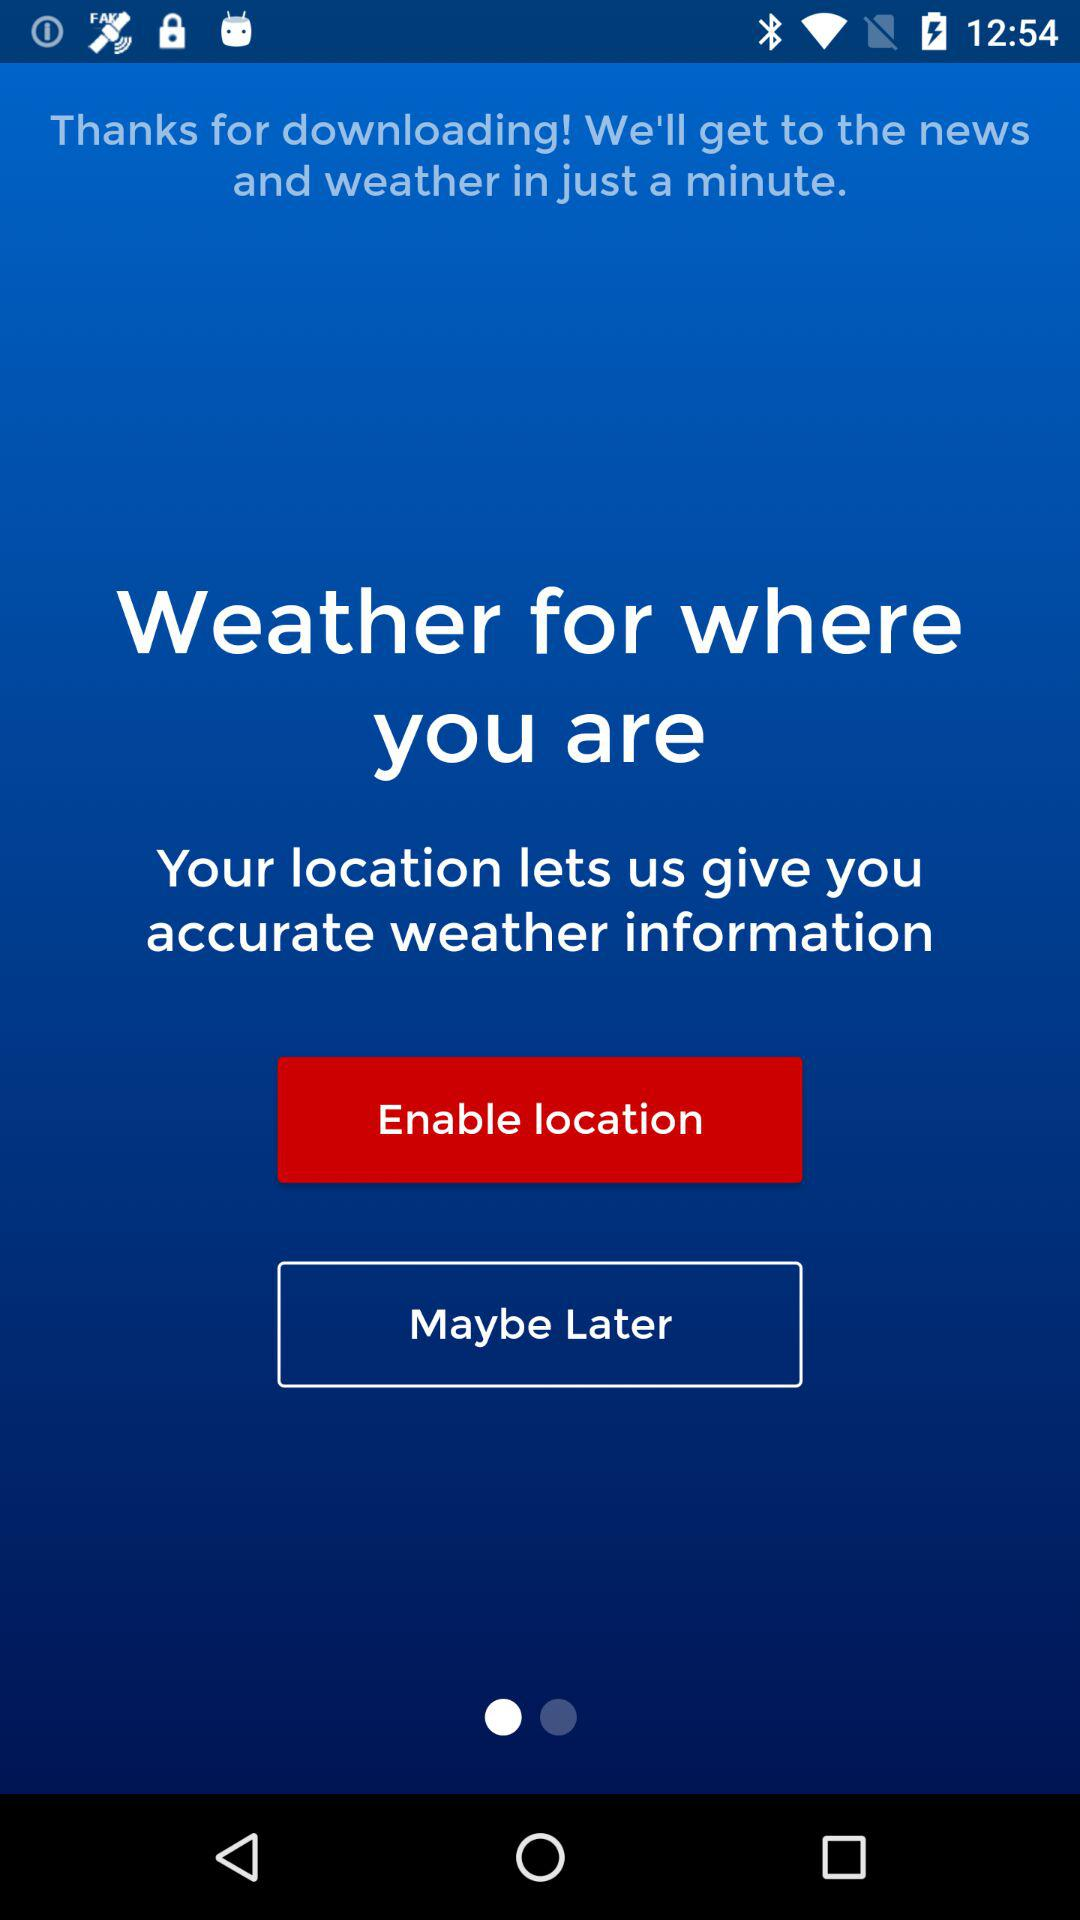How to know the exact weather location?
When the provided information is insufficient, respond with <no answer>. <no answer> 